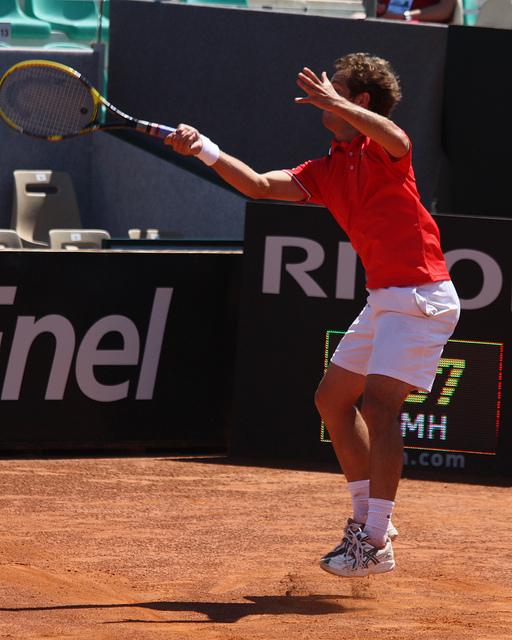Is the player's goal to meet the ball at eye level?
Short answer required. Yes. What sport is the man playing?
Be succinct. Tennis. What color is the man's shirt?
Short answer required. Red. Is the man jumping?
Quick response, please. Yes. What colors are on the ground?
Be succinct. Brown. 